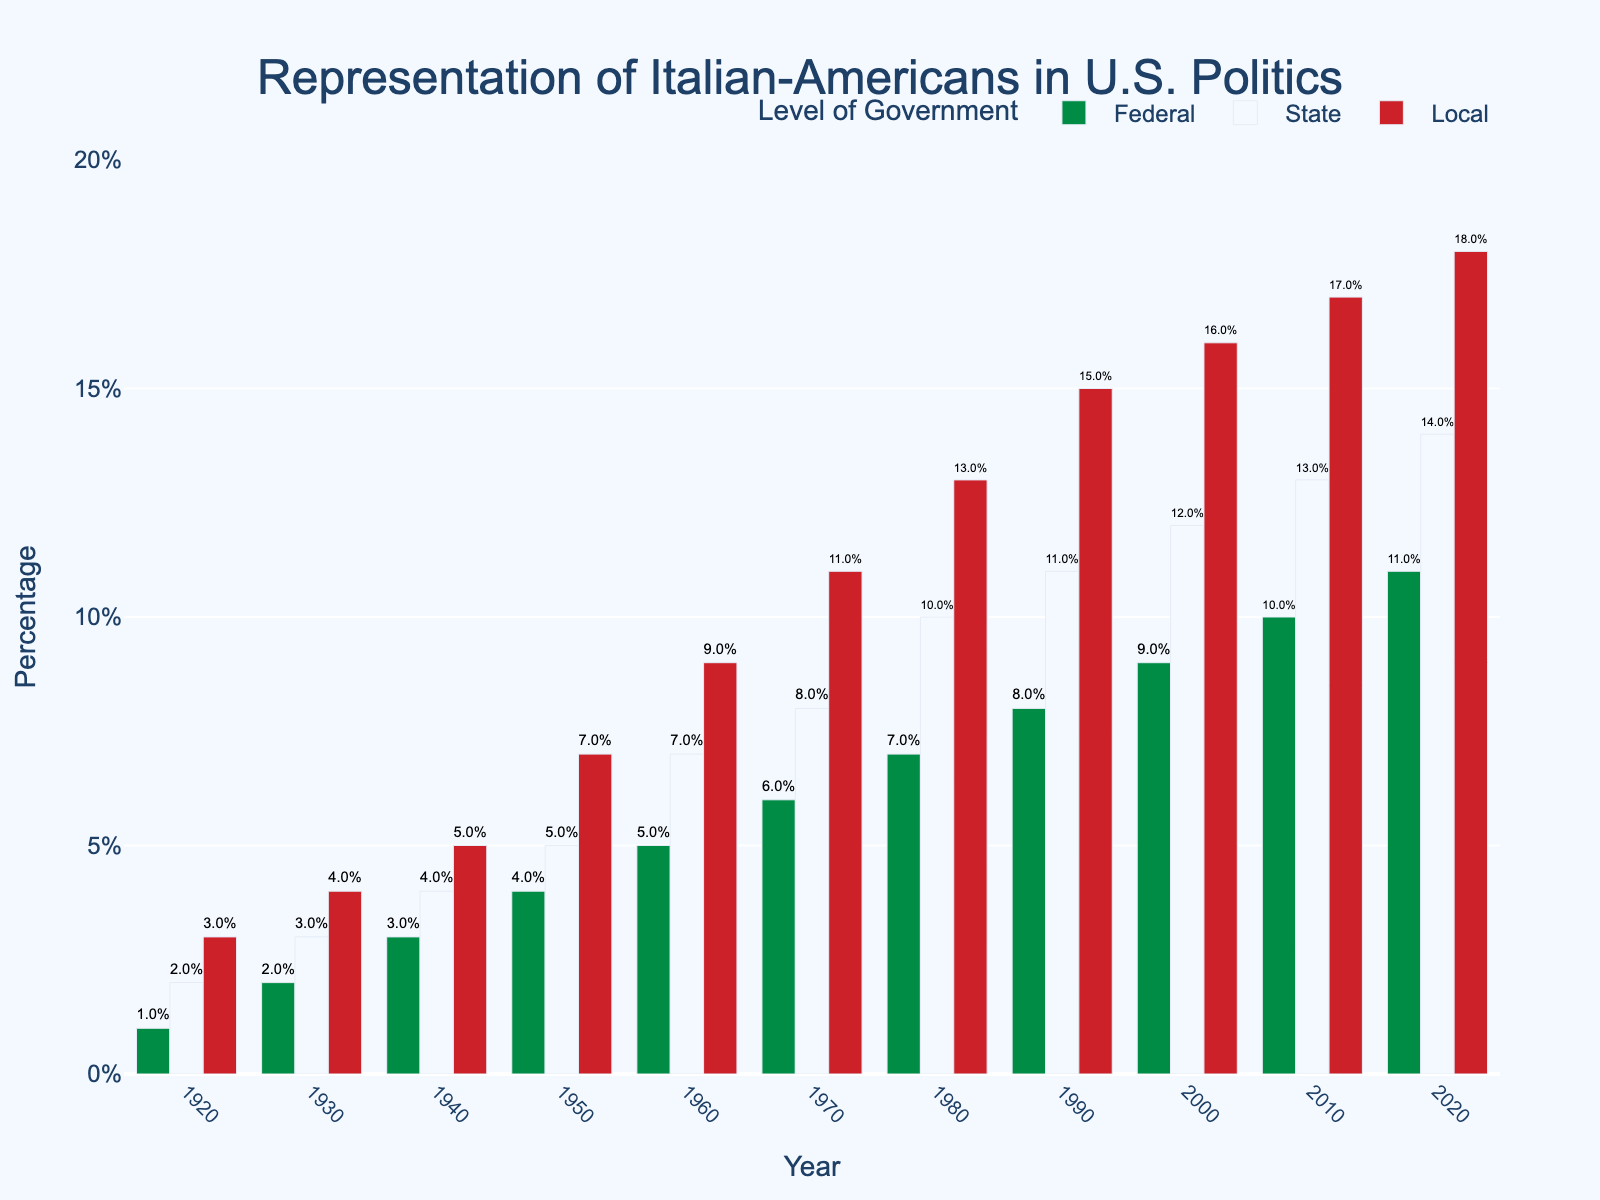what is the overall change in the percentage of Italian-Americans at the federal level from 1920 to 2020? The percentage of Italian-Americans at the federal level in 1920 was 1%. In 2020, it is 11%. The overall change is calculated by subtracting the initial percentage from the final percentage: 11% - 1% = 10%.
Answer: 10% compare the local representation of Italian-Americans in 1980 and 2000. Which year had a higher percentage? The percentage of Italian-Americans at the local level in 1980 was 13%, while in 2000, it was 16%. Comparing these values, 2000 had a higher percentage.
Answer: 2000 which level of government saw the highest percentage increase in representation from 1920 to 2020? For the federal level, the increase is from 1% to 11% (10%), for the state level, from 2% to 14% (12%), and for the local level, from 3% to 18% (15%). The local level saw the highest percentage increase.
Answer: Local how did the state-level representation change between 1940 and 1970? In 1940, the state-level representation was 4%, and in 1970, it was 8%. The change is calculated by subtracting the 1940 value from the 1970 value: 8% - 4% = 4%.
Answer: 4% what is the average percentage of Italian-Americans at the federal level from 1960 to 2020? The percentages at the federal level from 1960 to 2020 are: 5%, 6%, 7%, 8%, 9%, 10%, and 11%. Adding these values: 5 + 6 + 7 + 8 + 9 + 10 + 11 = 56. Dividing by the number of observations (7): 56 / 7 = 8%.
Answer: 8% which level of government had the smallest visual difference in height of bars between 1960 and 1980? Comparing the differences in height visually, the federal level bars increased from 5% to 7% (2%), state level from 7% to 10% (3%), and local level from 9% to 13% (4%). Thus, the federal level had the smallest visual difference.
Answer: Federal which year had the highest local representation and what was the percentage? By looking at the bars for local representation, the highest percentage is in the year 2020, with a percentage of 18%.
Answer: 2020 how many times did the federal level percentage of Italian-Americans double over the period from 1920 to 2020? The federal percentage doubled from 1% (1920) to 2% (1930), again from 2% to 4% (1950), and from 4% to 8% (1990). It did not double again to 16%. Therefore, it doubled three times.
Answer: Three times 